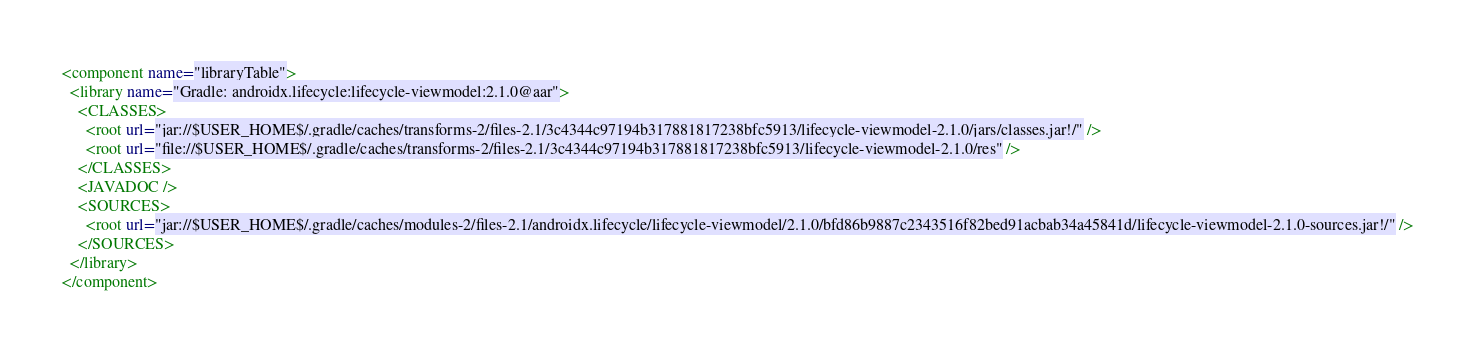<code> <loc_0><loc_0><loc_500><loc_500><_XML_><component name="libraryTable">
  <library name="Gradle: androidx.lifecycle:lifecycle-viewmodel:2.1.0@aar">
    <CLASSES>
      <root url="jar://$USER_HOME$/.gradle/caches/transforms-2/files-2.1/3c4344c97194b317881817238bfc5913/lifecycle-viewmodel-2.1.0/jars/classes.jar!/" />
      <root url="file://$USER_HOME$/.gradle/caches/transforms-2/files-2.1/3c4344c97194b317881817238bfc5913/lifecycle-viewmodel-2.1.0/res" />
    </CLASSES>
    <JAVADOC />
    <SOURCES>
      <root url="jar://$USER_HOME$/.gradle/caches/modules-2/files-2.1/androidx.lifecycle/lifecycle-viewmodel/2.1.0/bfd86b9887c2343516f82bed91acbab34a45841d/lifecycle-viewmodel-2.1.0-sources.jar!/" />
    </SOURCES>
  </library>
</component></code> 